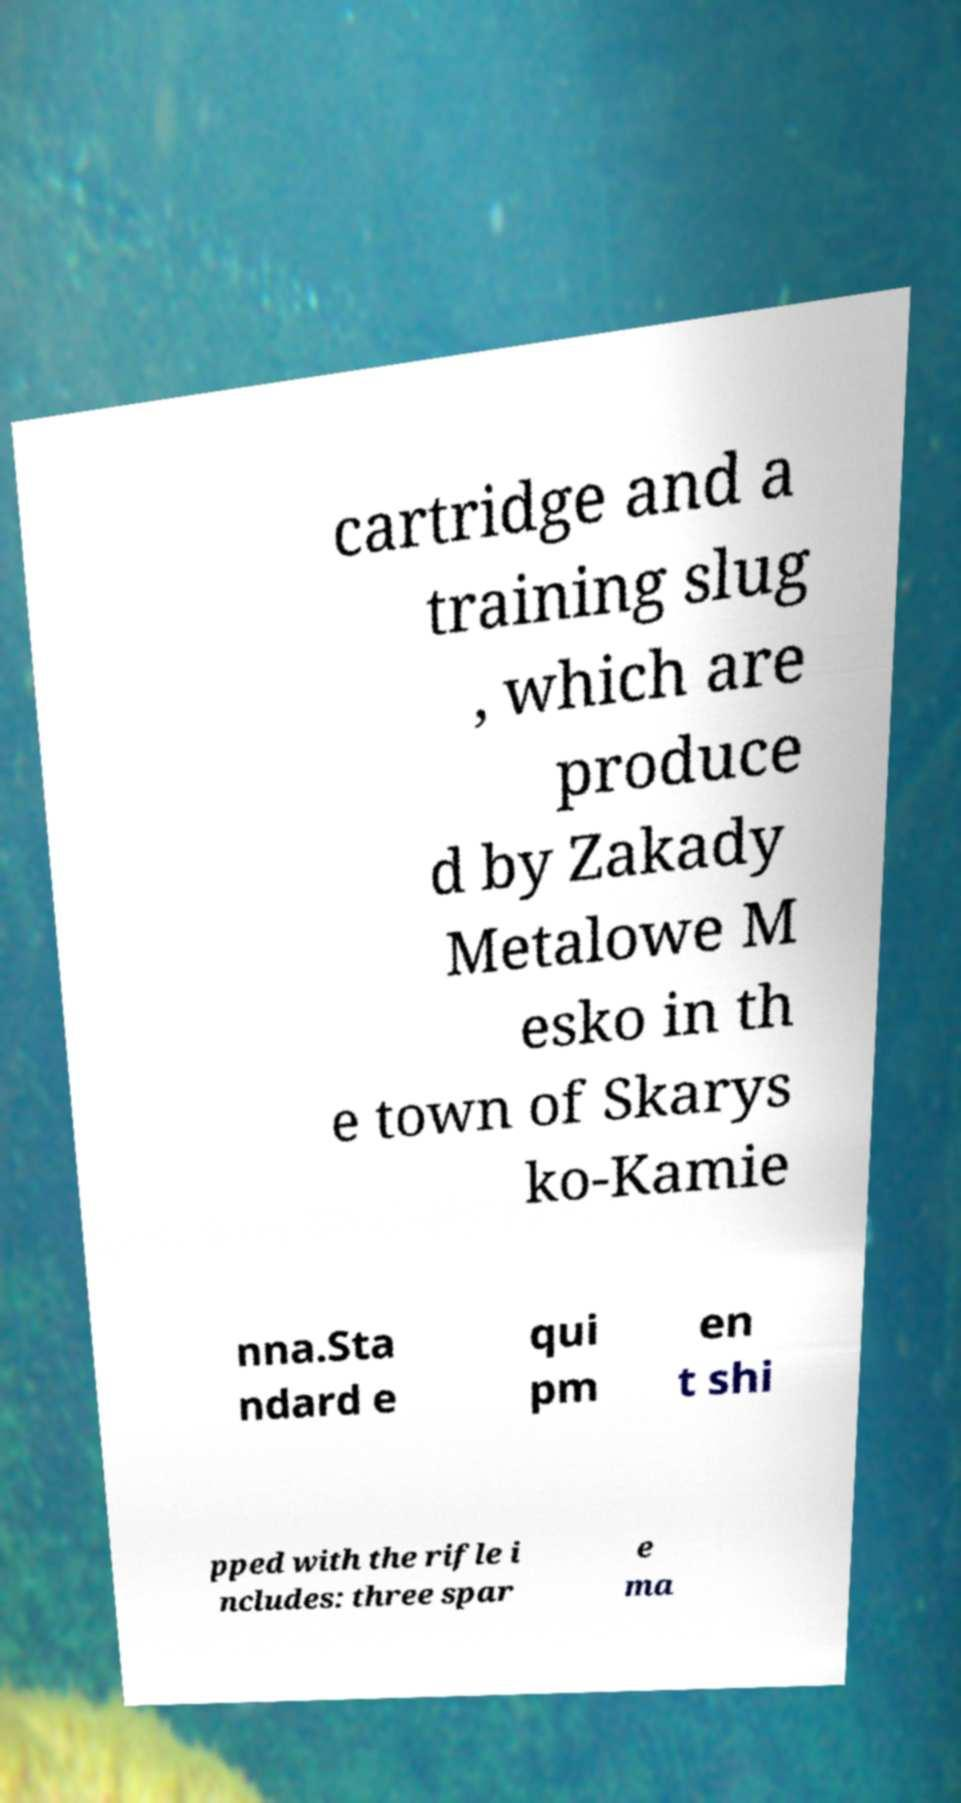Please read and relay the text visible in this image. What does it say? cartridge and a training slug , which are produce d by Zakady Metalowe M esko in th e town of Skarys ko-Kamie nna.Sta ndard e qui pm en t shi pped with the rifle i ncludes: three spar e ma 